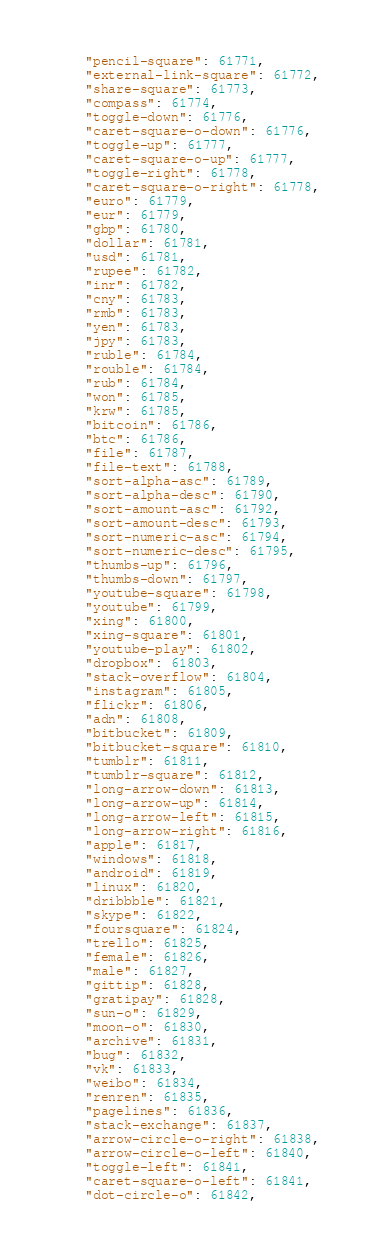Convert code to text. <code><loc_0><loc_0><loc_500><loc_500><_JavaScript_>	"pencil-square": 61771,
	"external-link-square": 61772,
	"share-square": 61773,
	"compass": 61774,
	"toggle-down": 61776,
	"caret-square-o-down": 61776,
	"toggle-up": 61777,
	"caret-square-o-up": 61777,
	"toggle-right": 61778,
	"caret-square-o-right": 61778,
	"euro": 61779,
	"eur": 61779,
	"gbp": 61780,
	"dollar": 61781,
	"usd": 61781,
	"rupee": 61782,
	"inr": 61782,
	"cny": 61783,
	"rmb": 61783,
	"yen": 61783,
	"jpy": 61783,
	"ruble": 61784,
	"rouble": 61784,
	"rub": 61784,
	"won": 61785,
	"krw": 61785,
	"bitcoin": 61786,
	"btc": 61786,
	"file": 61787,
	"file-text": 61788,
	"sort-alpha-asc": 61789,
	"sort-alpha-desc": 61790,
	"sort-amount-asc": 61792,
	"sort-amount-desc": 61793,
	"sort-numeric-asc": 61794,
	"sort-numeric-desc": 61795,
	"thumbs-up": 61796,
	"thumbs-down": 61797,
	"youtube-square": 61798,
	"youtube": 61799,
	"xing": 61800,
	"xing-square": 61801,
	"youtube-play": 61802,
	"dropbox": 61803,
	"stack-overflow": 61804,
	"instagram": 61805,
	"flickr": 61806,
	"adn": 61808,
	"bitbucket": 61809,
	"bitbucket-square": 61810,
	"tumblr": 61811,
	"tumblr-square": 61812,
	"long-arrow-down": 61813,
	"long-arrow-up": 61814,
	"long-arrow-left": 61815,
	"long-arrow-right": 61816,
	"apple": 61817,
	"windows": 61818,
	"android": 61819,
	"linux": 61820,
	"dribbble": 61821,
	"skype": 61822,
	"foursquare": 61824,
	"trello": 61825,
	"female": 61826,
	"male": 61827,
	"gittip": 61828,
	"gratipay": 61828,
	"sun-o": 61829,
	"moon-o": 61830,
	"archive": 61831,
	"bug": 61832,
	"vk": 61833,
	"weibo": 61834,
	"renren": 61835,
	"pagelines": 61836,
	"stack-exchange": 61837,
	"arrow-circle-o-right": 61838,
	"arrow-circle-o-left": 61840,
	"toggle-left": 61841,
	"caret-square-o-left": 61841,
	"dot-circle-o": 61842,</code> 